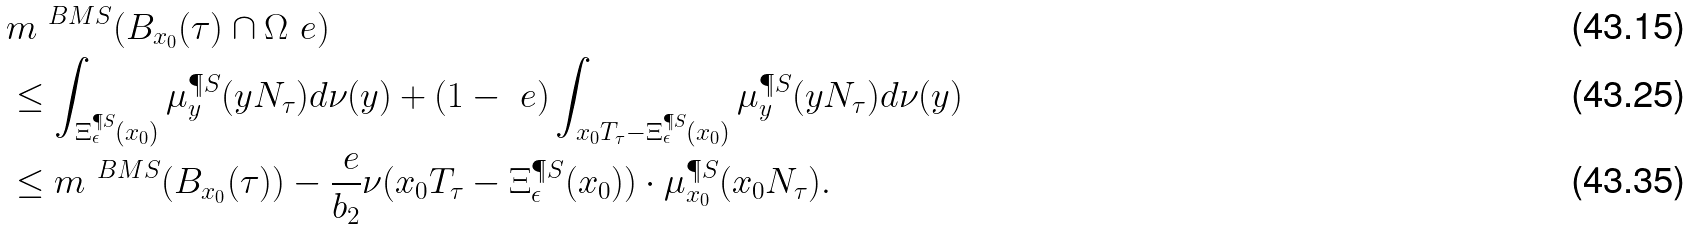Convert formula to latex. <formula><loc_0><loc_0><loc_500><loc_500>& m ^ { \ B M S } ( B _ { x _ { 0 } } ( \tau ) \cap \Omega _ { \ } e ) \\ & \leq \int _ { \Xi _ { \epsilon } ^ { \P S } ( x _ { 0 } ) } \mu _ { y } ^ { \P S } ( y N _ { \tau } ) d \nu ( y ) + ( 1 - \ e ) \int _ { x _ { 0 } T _ { \tau } - \Xi _ { \epsilon } ^ { \P S } ( x _ { 0 } ) } \mu _ { y } ^ { \P S } ( y N _ { \tau } ) d \nu ( y ) \\ & \leq m ^ { \ B M S } ( B _ { x _ { 0 } } ( \tau ) ) - \frac { \ e } { b _ { 2 } } \nu ( x _ { 0 } T _ { \tau } - \Xi _ { \epsilon } ^ { \P S } ( x _ { 0 } ) ) \cdot \mu _ { x _ { 0 } } ^ { \P S } ( x _ { 0 } N _ { \tau } ) .</formula> 